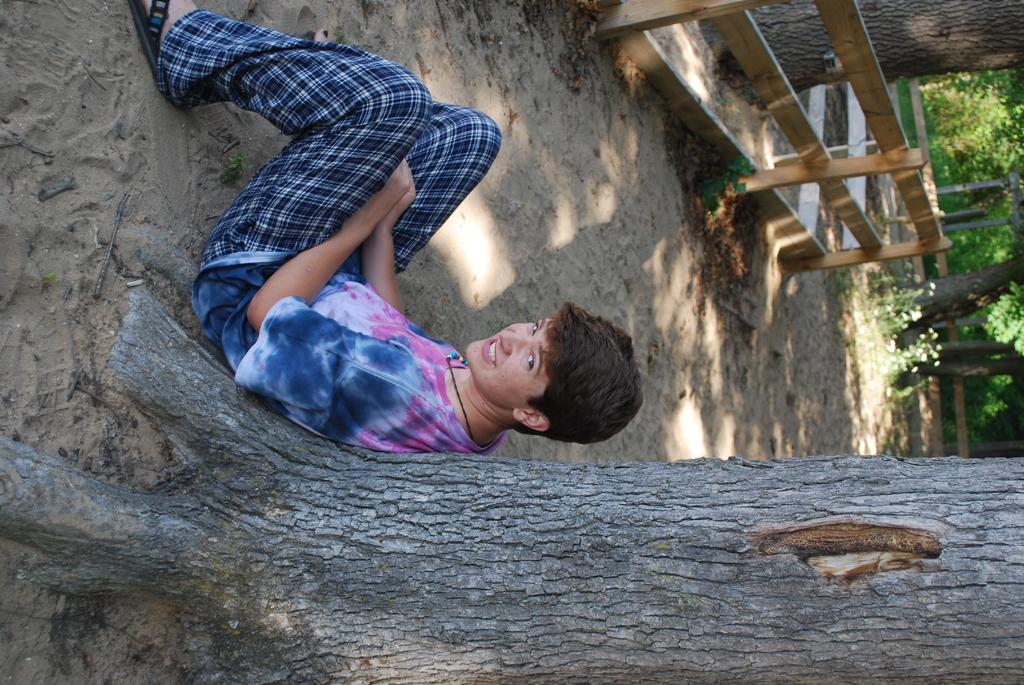What can be seen in the image? There is a person in the image. What is the person wearing? The person is wearing a dress. What is visible behind the person? There is a tree trunk visible behind the person. What can be seen in the background of the image? There is a fence and many trees in the background of the image. What type of leather is used to make the chair in the image? There is no chair present in the image, so it is not possible to determine the type of leather used. 